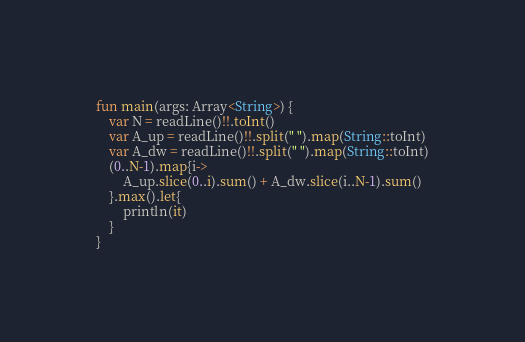Convert code to text. <code><loc_0><loc_0><loc_500><loc_500><_Kotlin_>fun main(args: Array<String>) {
    var N = readLine()!!.toInt()
    var A_up = readLine()!!.split(" ").map(String::toInt)
    var A_dw = readLine()!!.split(" ").map(String::toInt)
    (0..N-1).map{i->
        A_up.slice(0..i).sum() + A_dw.slice(i..N-1).sum()
    }.max().let{
        println(it)
    }
}</code> 